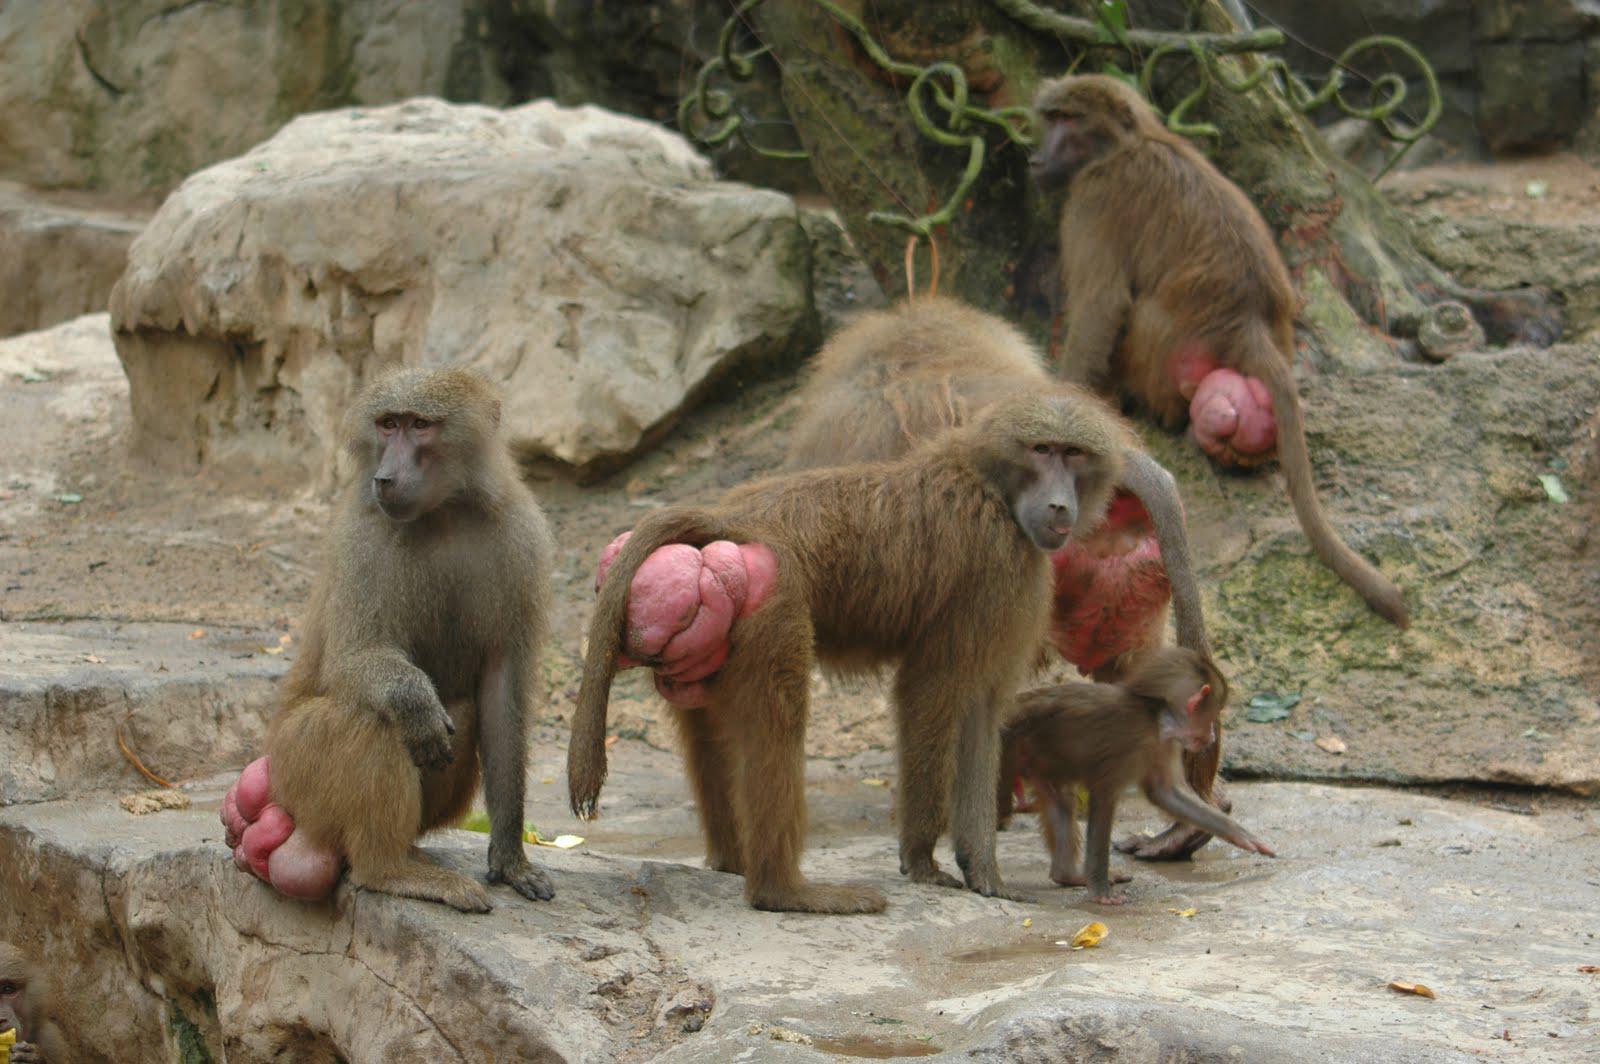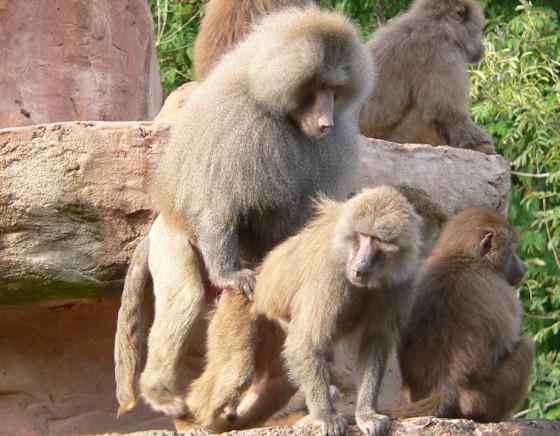The first image is the image on the left, the second image is the image on the right. Assess this claim about the two images: "One animal is on another animal's back in one of the images.". Correct or not? Answer yes or no. Yes. The first image is the image on the left, the second image is the image on the right. Evaluate the accuracy of this statement regarding the images: "An image shows two sitting adult monkeys, plus a smaller monkey in the middle of the scene.". Is it true? Answer yes or no. No. 